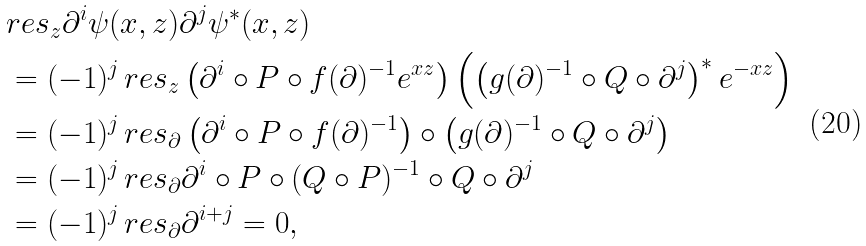Convert formula to latex. <formula><loc_0><loc_0><loc_500><loc_500>& r e s _ { z } \partial ^ { i } \psi ( x , z ) \partial ^ { j } \psi ^ { * } ( x , z ) \\ & = ( - 1 ) ^ { j } \, r e s _ { z } \left ( \partial ^ { i } \circ P \circ f ( \partial ) ^ { - 1 } e ^ { x z } \right ) \left ( \left ( g ( \partial ) ^ { - 1 } \circ Q \circ \partial ^ { j } \right ) ^ { * } e ^ { - x z } \right ) \\ & = ( - 1 ) ^ { j } \, r e s _ { \partial } \left ( \partial ^ { i } \circ P \circ f ( \partial ) ^ { - 1 } \right ) \circ \left ( g ( \partial ) ^ { - 1 } \circ Q \circ \partial ^ { j } \right ) \\ & = ( - 1 ) ^ { j } \, r e s _ { \partial } \partial ^ { i } \circ P \circ ( Q \circ P ) ^ { - 1 } \circ Q \circ \partial ^ { j } \\ & = ( - 1 ) ^ { j } \, r e s _ { \partial } \partial ^ { i + j } = 0 ,</formula> 